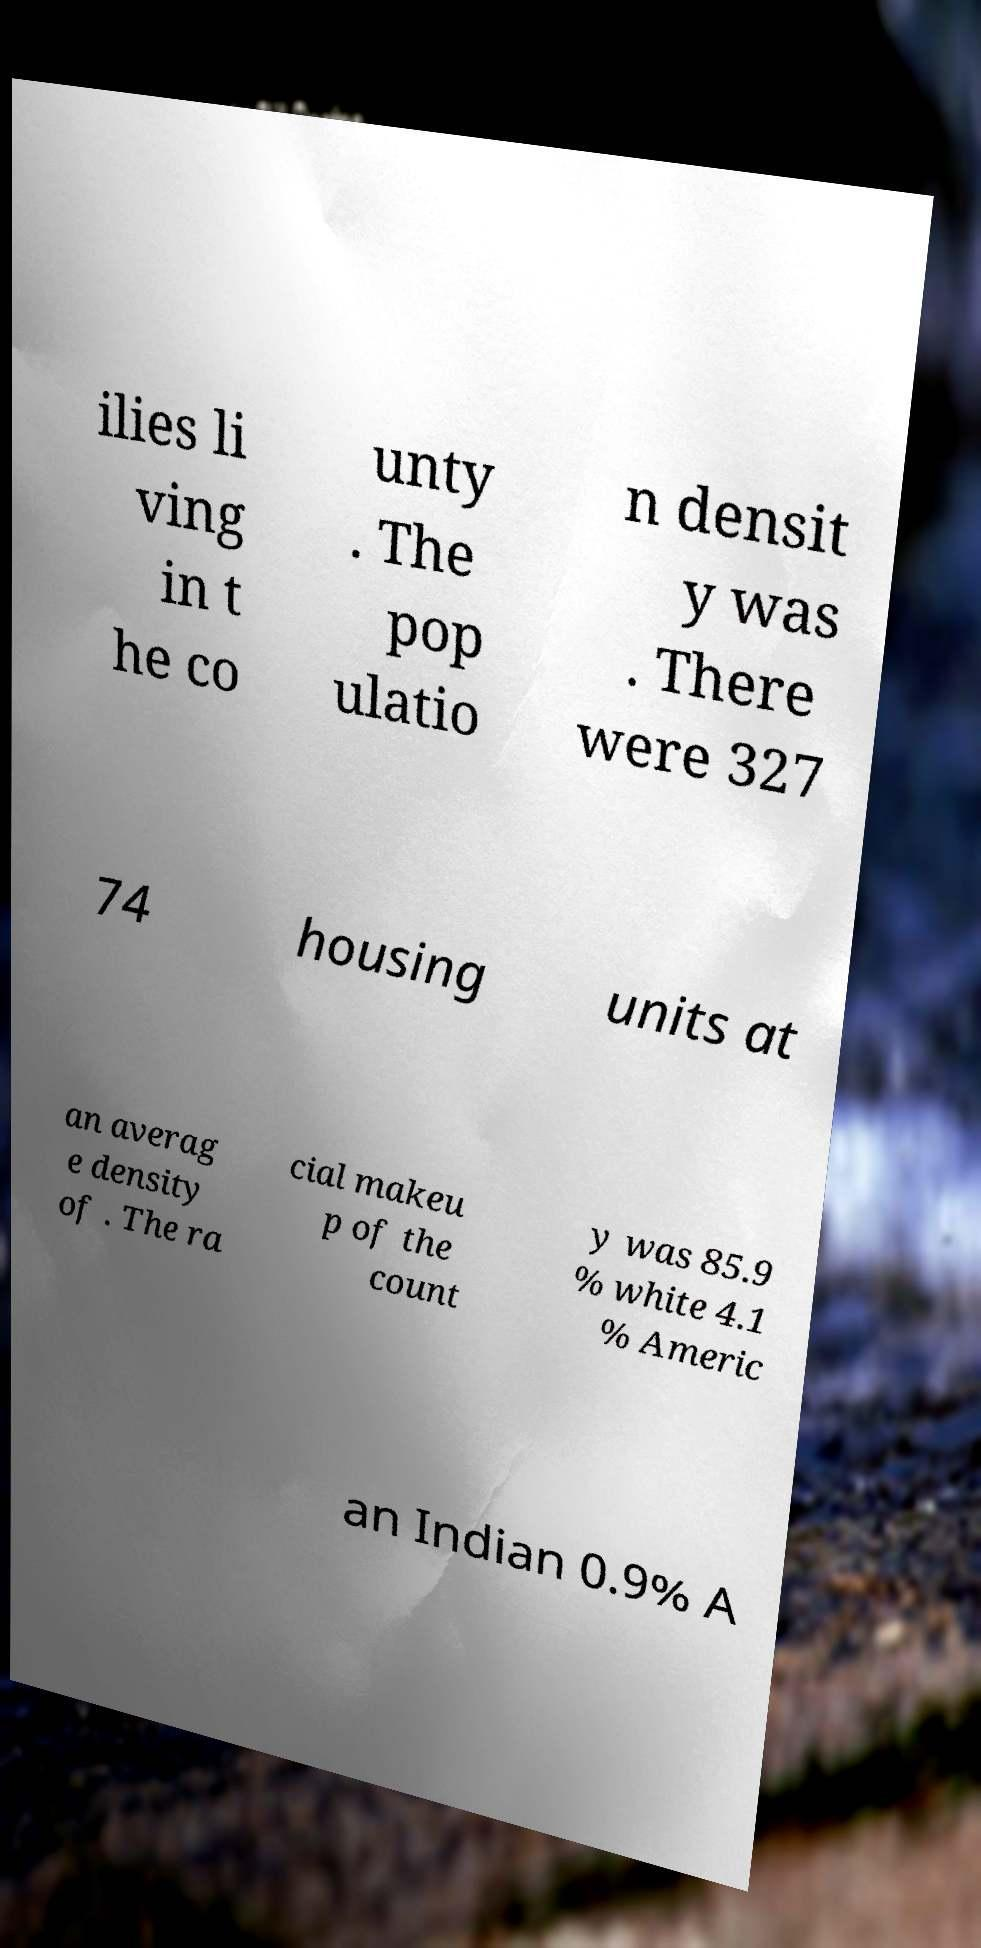Please read and relay the text visible in this image. What does it say? ilies li ving in t he co unty . The pop ulatio n densit y was . There were 327 74 housing units at an averag e density of . The ra cial makeu p of the count y was 85.9 % white 4.1 % Americ an Indian 0.9% A 